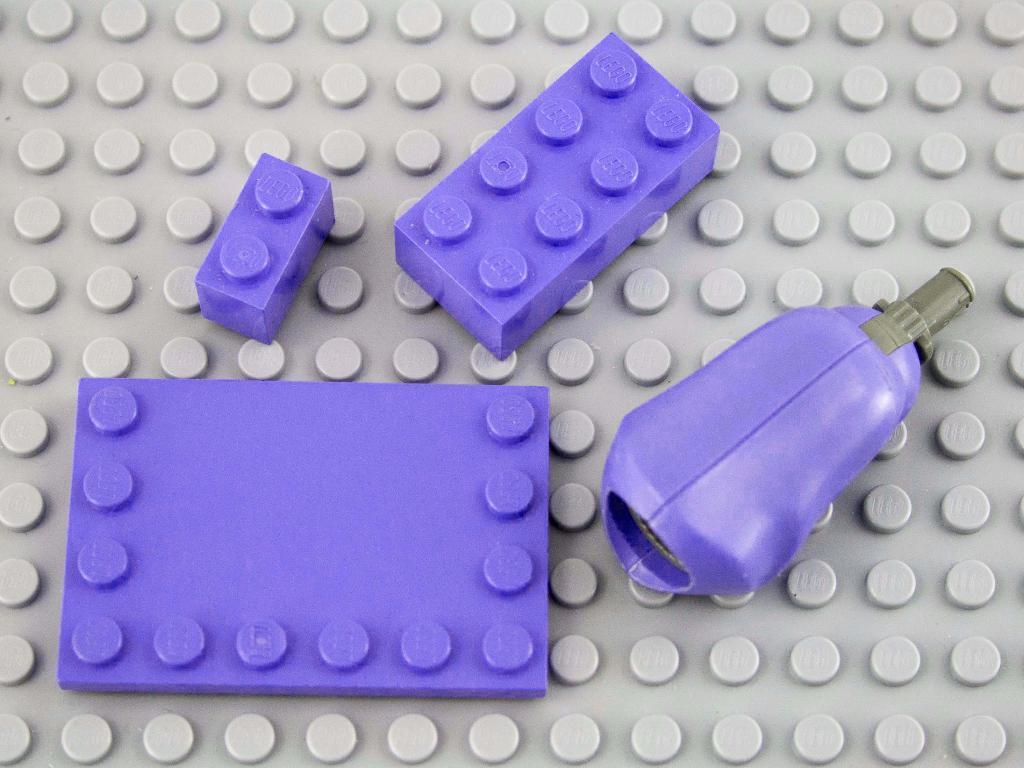How would you summarize this image in a sentence or two? In this image we can see purple color objects are present on a grey color object. 